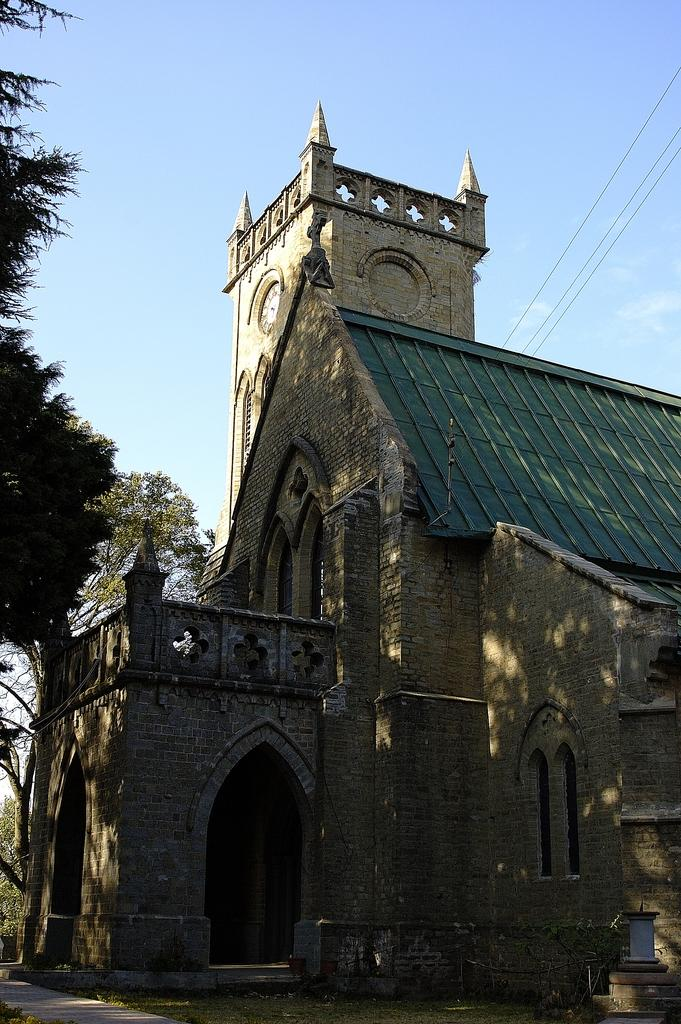What type of surface can be seen in the image? There is ground visible in the image. What is the main structure in the image? There is a huge building in the image. What colors are used for the building? The building is black, green, and cream in color. What type of vegetation is present in the image? There are trees in the image. What can be seen in the distance in the image? The sky is visible in the background of the image. What type of stove is used in the church depicted in the image? There is no church or stove present in the image. 